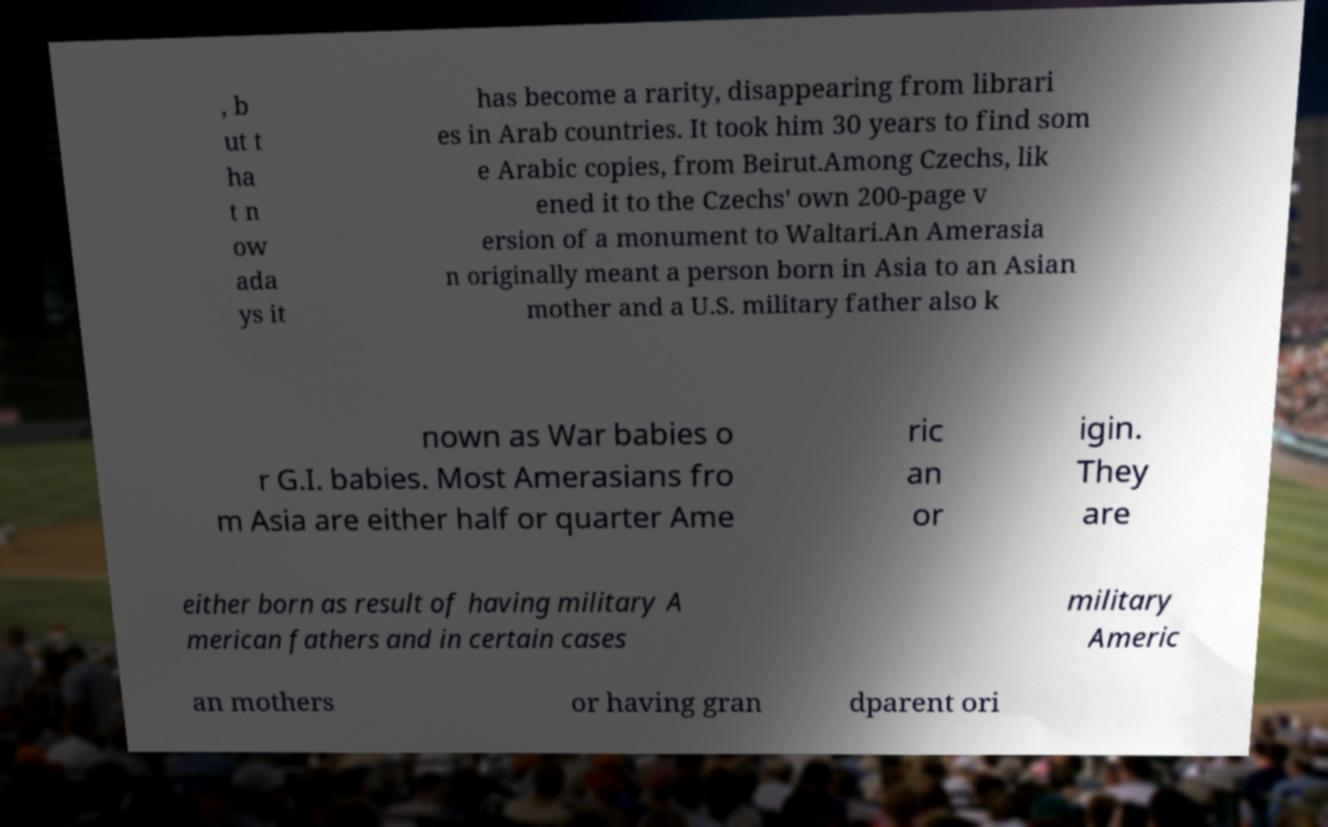Please identify and transcribe the text found in this image. , b ut t ha t n ow ada ys it has become a rarity, disappearing from librari es in Arab countries. It took him 30 years to find som e Arabic copies, from Beirut.Among Czechs, lik ened it to the Czechs' own 200-page v ersion of a monument to Waltari.An Amerasia n originally meant a person born in Asia to an Asian mother and a U.S. military father also k nown as War babies o r G.I. babies. Most Amerasians fro m Asia are either half or quarter Ame ric an or igin. They are either born as result of having military A merican fathers and in certain cases military Americ an mothers or having gran dparent ori 